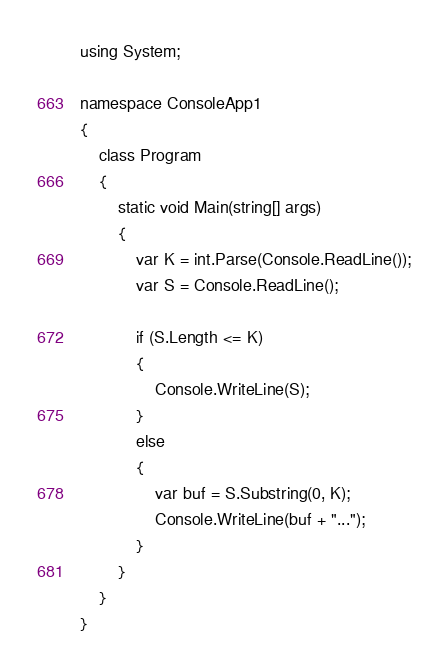<code> <loc_0><loc_0><loc_500><loc_500><_C#_>using System;

namespace ConsoleApp1
{
    class Program
    {
        static void Main(string[] args)
        {
            var K = int.Parse(Console.ReadLine());
            var S = Console.ReadLine();

            if (S.Length <= K)
            {
                Console.WriteLine(S);
            }
            else
            {
                var buf = S.Substring(0, K);
                Console.WriteLine(buf + "...");
            }
        }
    }
}</code> 